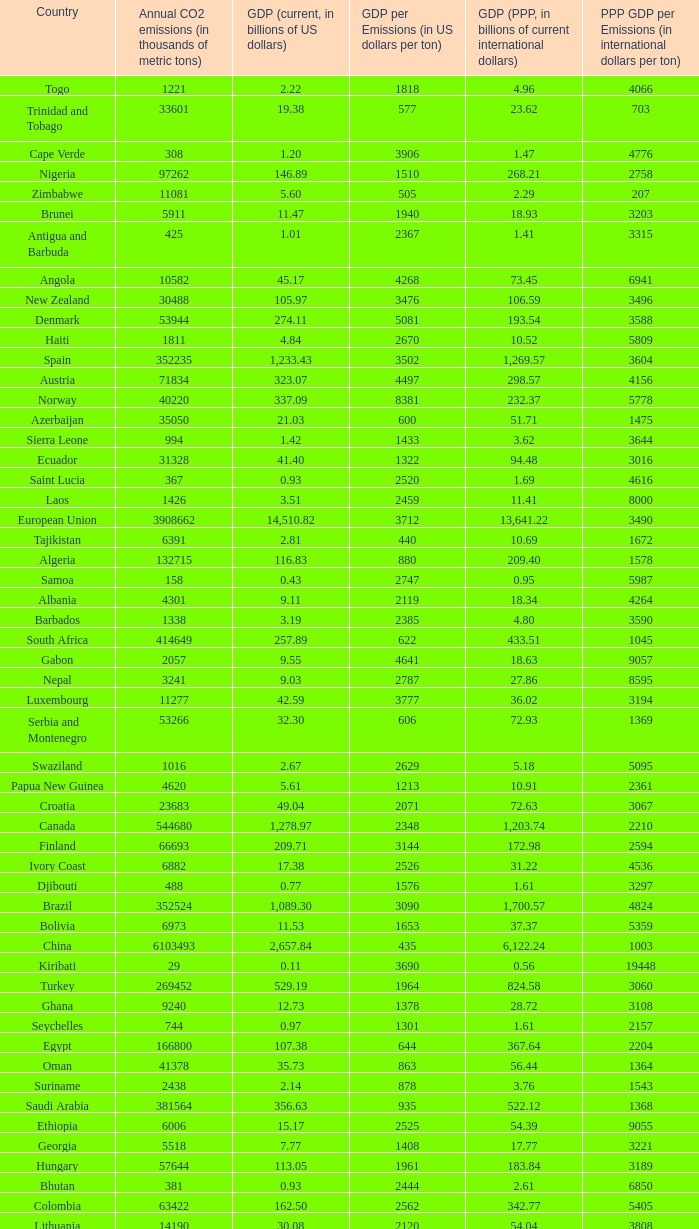When the gdp (current, in billions of us dollars) is 162.50, what is the gdp? 2562.0. 